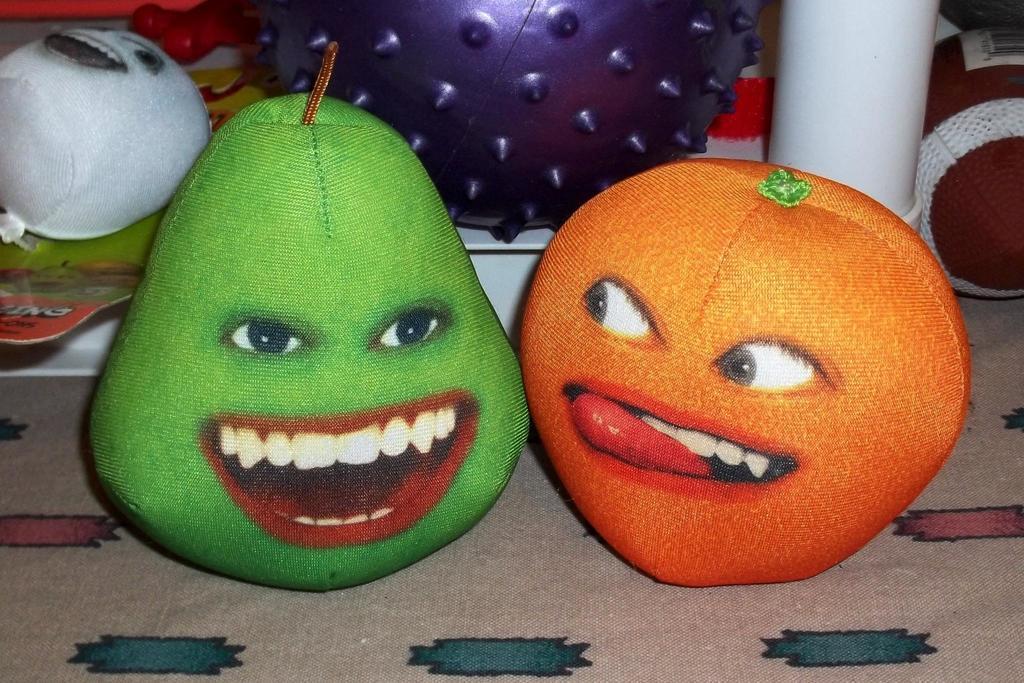Can you describe this image briefly? In this image we can see few toys on the cloth. 